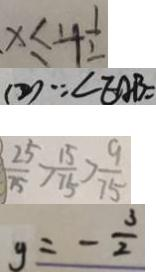Convert formula to latex. <formula><loc_0><loc_0><loc_500><loc_500>x \leq 4 \frac { 1 } { 2 } 
 ( 2 ) \because \angle E A B = 
 \frac { 2 5 } { 7 5 } > \frac { 1 5 } { 7 5 } > \frac { 9 } { 7 5 } 
 y = - \frac { 3 } { 2 }</formula> 